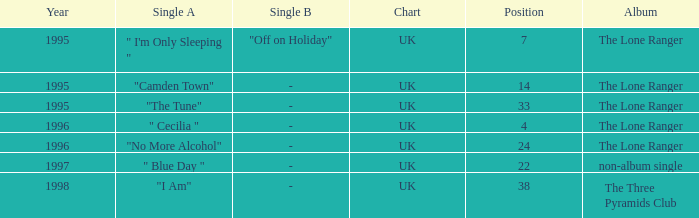Write the full table. {'header': ['Year', 'Single A', 'Single B', 'Chart', 'Position', 'Album'], 'rows': [['1995', '" I\'m Only Sleeping "', '"Off on Holiday"', 'UK', '7', 'The Lone Ranger'], ['1995', '"Camden Town"', '-', 'UK', '14', 'The Lone Ranger'], ['1995', '"The Tune"', '-', 'UK', '33', 'The Lone Ranger'], ['1996', '" Cecilia "', '-', 'UK', '4', 'The Lone Ranger'], ['1996', '"No More Alcohol"', '-', 'UK', '24', 'The Lone Ranger'], ['1997', '" Blue Day "', '-', 'UK', '22', 'non-album single'], ['1998', '"I Am"', '-', 'UK', '38', 'The Three Pyramids Club']]} When the position is less than 7, what is the appeared on album? The Lone Ranger. 